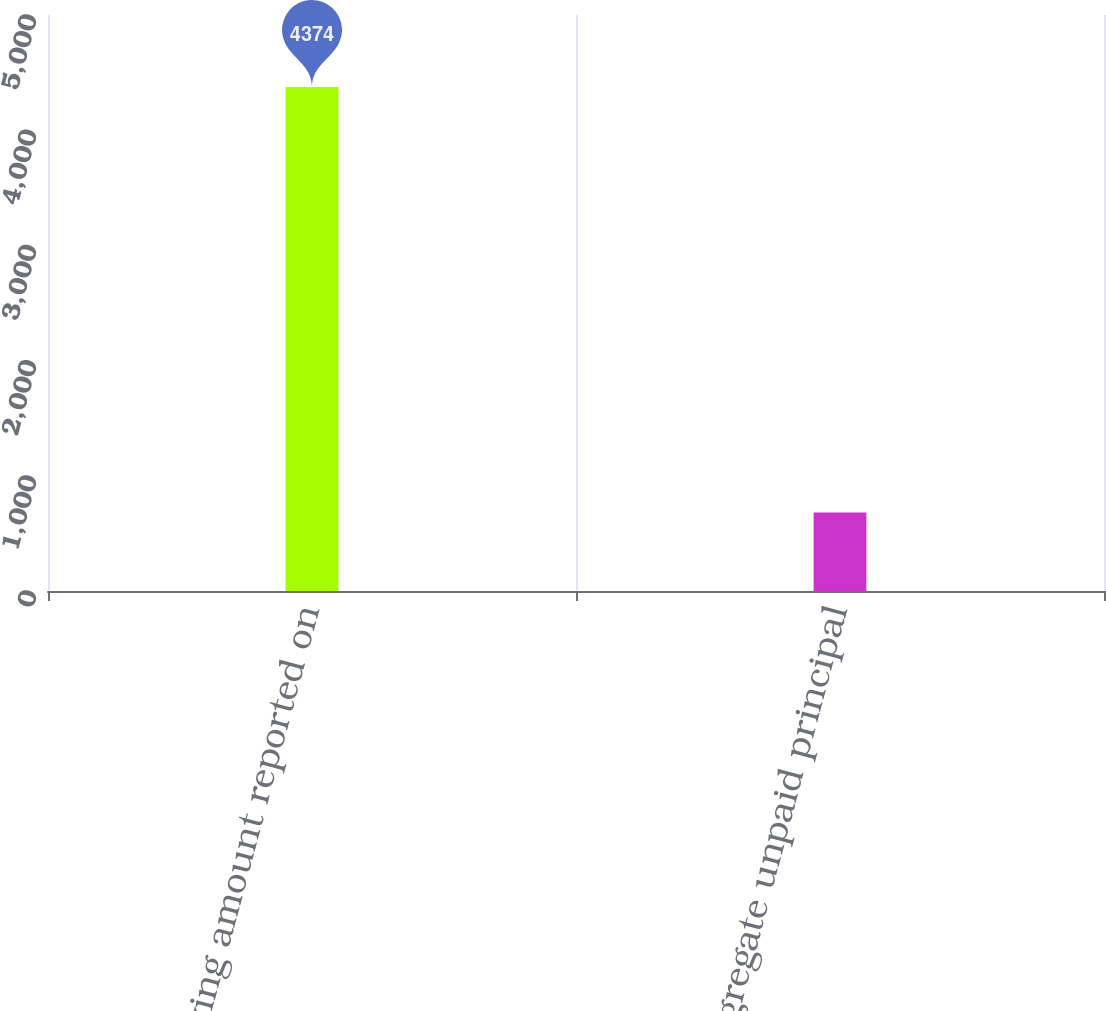Convert chart to OTSL. <chart><loc_0><loc_0><loc_500><loc_500><bar_chart><fcel>Carrying amount reported on<fcel>Aggregate unpaid principal<nl><fcel>4374<fcel>682<nl></chart> 